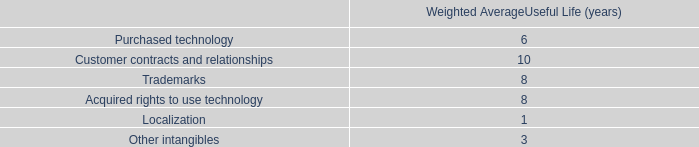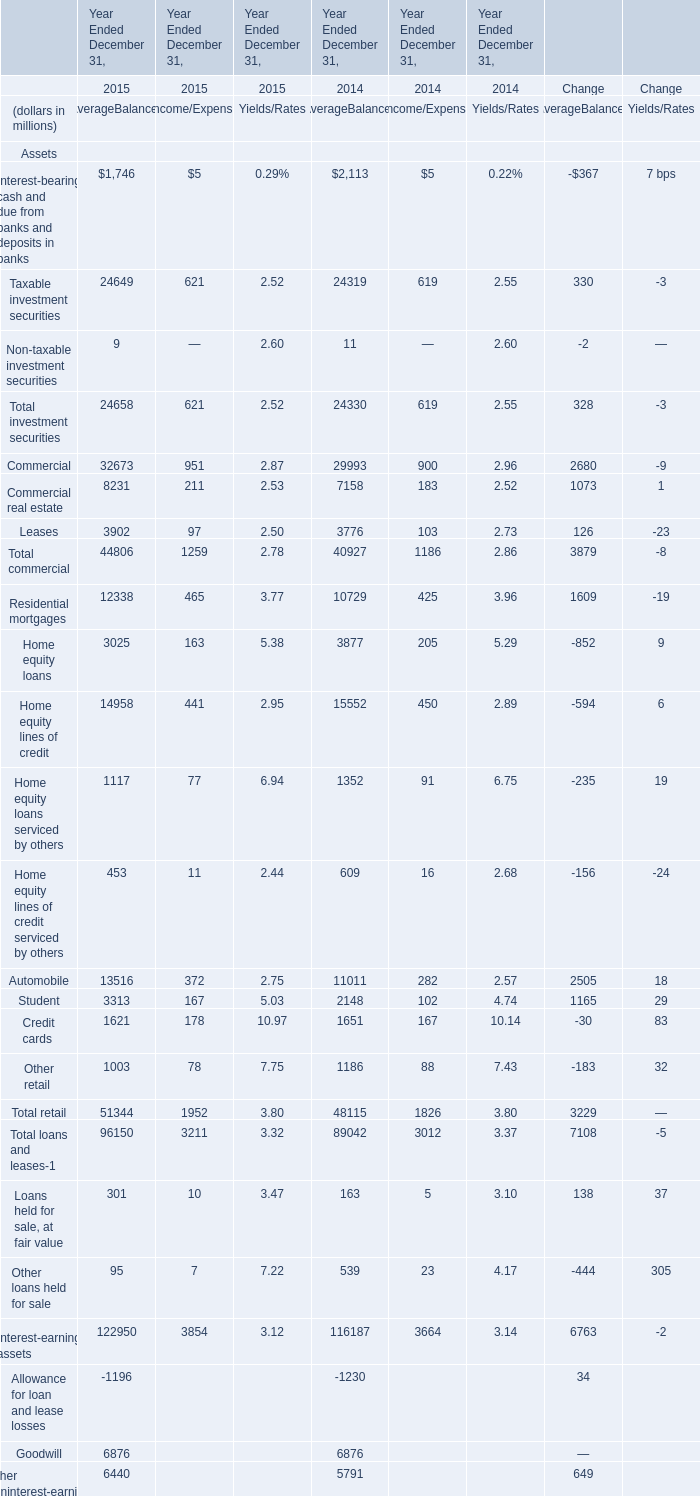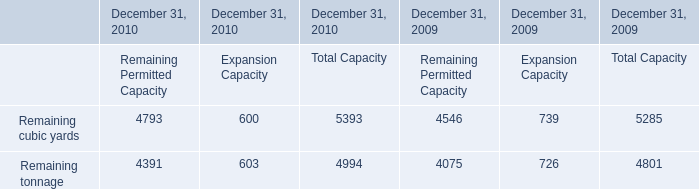What is the average amount of Remaining cubic yards of December 31, 2010 Remaining Permitted Capacity, and Taxable investment securities of Year Ended December 31, 2014 AverageBalances ? 
Computations: ((4793.0 + 24319.0) / 2)
Answer: 14556.0. 